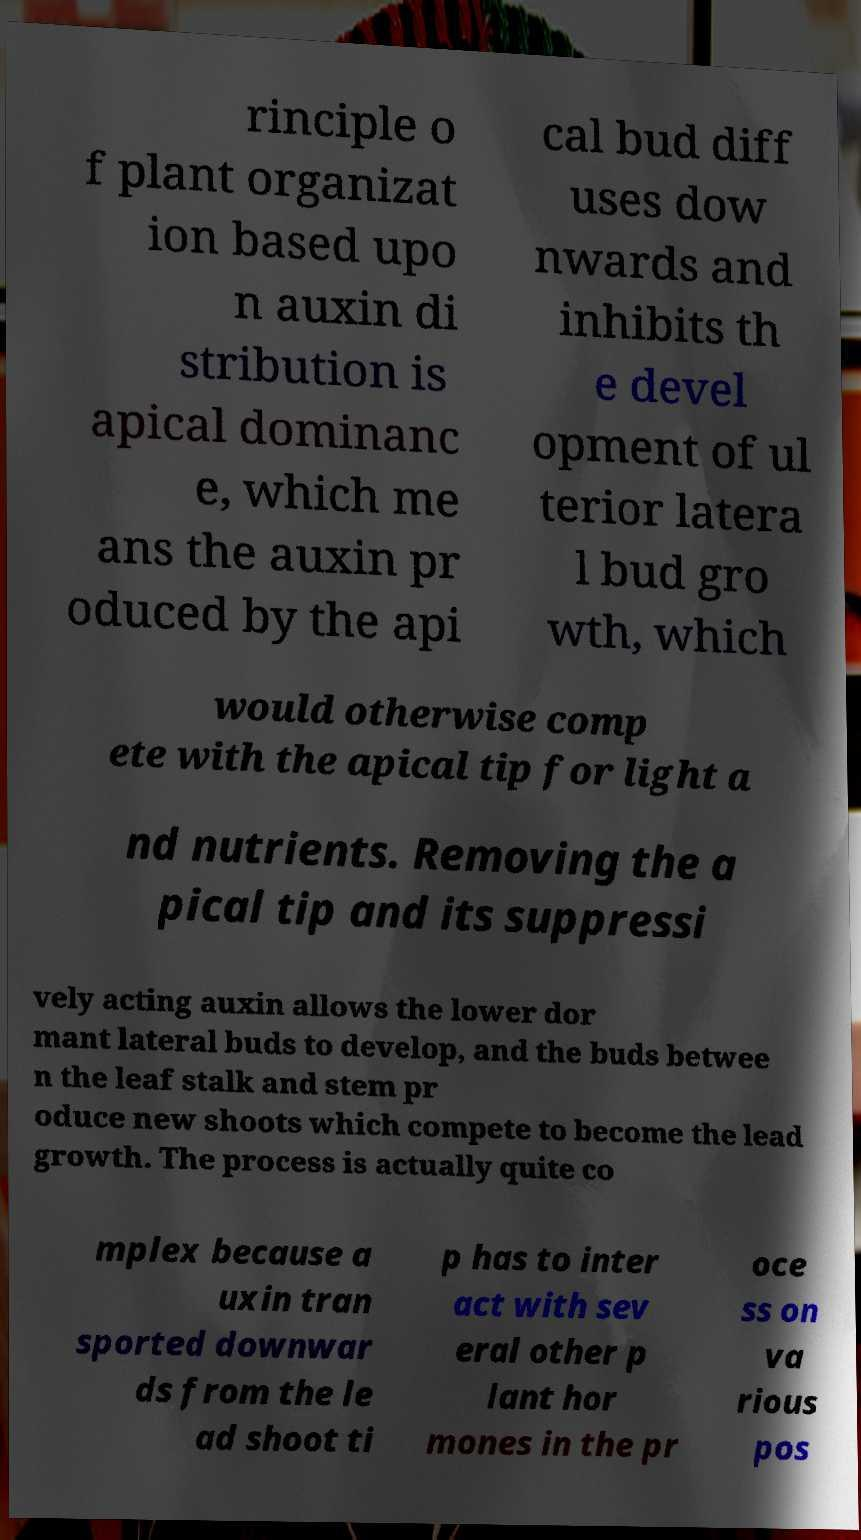I need the written content from this picture converted into text. Can you do that? rinciple o f plant organizat ion based upo n auxin di stribution is apical dominanc e, which me ans the auxin pr oduced by the api cal bud diff uses dow nwards and inhibits th e devel opment of ul terior latera l bud gro wth, which would otherwise comp ete with the apical tip for light a nd nutrients. Removing the a pical tip and its suppressi vely acting auxin allows the lower dor mant lateral buds to develop, and the buds betwee n the leaf stalk and stem pr oduce new shoots which compete to become the lead growth. The process is actually quite co mplex because a uxin tran sported downwar ds from the le ad shoot ti p has to inter act with sev eral other p lant hor mones in the pr oce ss on va rious pos 